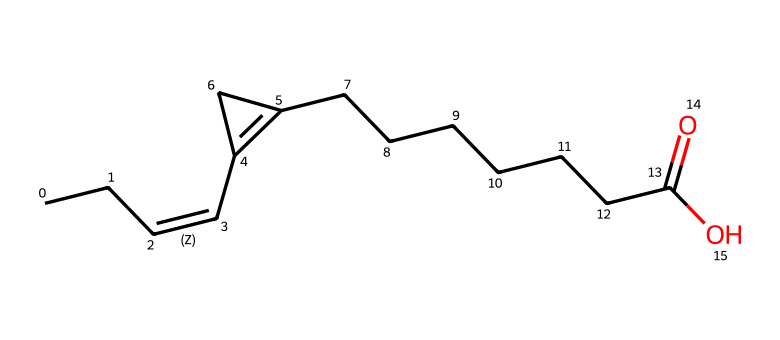What is the main functional group present in malvalic acid? The chemical structure shows a carboxylic acid functional group, indicated by the presence of the carbon atom bonded to a hydroxyl (-OH) group and a double-bonded oxygen (=O) in the terminal part of the molecule.
Answer: carboxylic acid How many chiral centers are present in malvalic acid? By examining the structure, there is one chiral center located at the carbon that is attached to four different substituents (a carbon chain, a cyclopropene group, a hydrogen atom, and the carboxylic acid).
Answer: one What is the total number of carbon atoms in malvalic acid? Counting the carbon atoms in the structure, there are a total of 13 carbon atoms present in the entire molecule, including those in the carboxylic acid and the fatty acid chain.
Answer: thirteen How does the cyclopropene affect the reactivity of malvalic acid? The presence of the cyclopropene, which is a three-membered ring, introduces ring strain, making the compound more reactive compared to typical fatty acids, as it can undergo various reactions like ring-opening.
Answer: increases reactivity What is the significance of chirality in malvalic acid's biological activity? Chirality can influence the biological interactions of the molecule, as different enantiomers may have varying effects on biological systems or receptors, potentially leading to diverse physiological responses.
Answer: varies biologically What type of bond is present between the carbons in the double bond of malvalic acid? The double bond is a carbon-carbon double bond (C=C), which is characterized by one sigma bond and one pi bond formed from the overlap of p orbitals.
Answer: double bond 